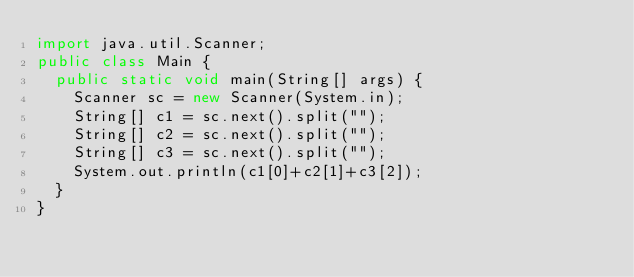Convert code to text. <code><loc_0><loc_0><loc_500><loc_500><_Java_>import java.util.Scanner;
public class Main {
	public static void main(String[] args) {
		Scanner sc = new Scanner(System.in);
		String[] c1 = sc.next().split("");
		String[] c2 = sc.next().split("");
		String[] c3 = sc.next().split("");
		System.out.println(c1[0]+c2[1]+c3[2]);
	}
}</code> 